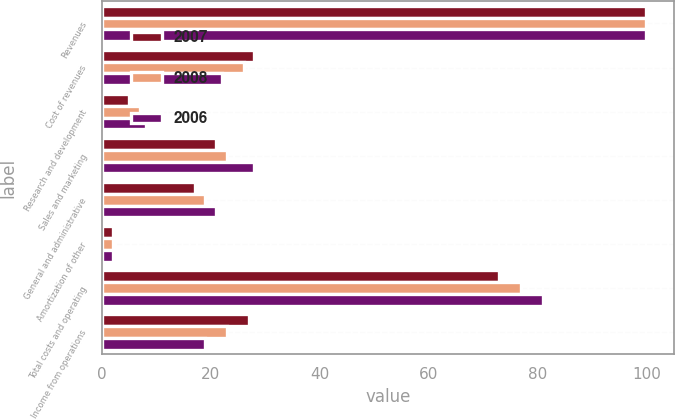Convert chart. <chart><loc_0><loc_0><loc_500><loc_500><stacked_bar_chart><ecel><fcel>Revenues<fcel>Cost of revenues<fcel>Research and development<fcel>Sales and marketing<fcel>General and administrative<fcel>Amortization of other<fcel>Total costs and operating<fcel>Income from operations<nl><fcel>2007<fcel>100<fcel>28<fcel>5<fcel>21<fcel>17<fcel>2<fcel>73<fcel>27<nl><fcel>2008<fcel>100<fcel>26<fcel>7<fcel>23<fcel>19<fcel>2<fcel>77<fcel>23<nl><fcel>2006<fcel>100<fcel>22<fcel>8<fcel>28<fcel>21<fcel>2<fcel>81<fcel>19<nl></chart> 